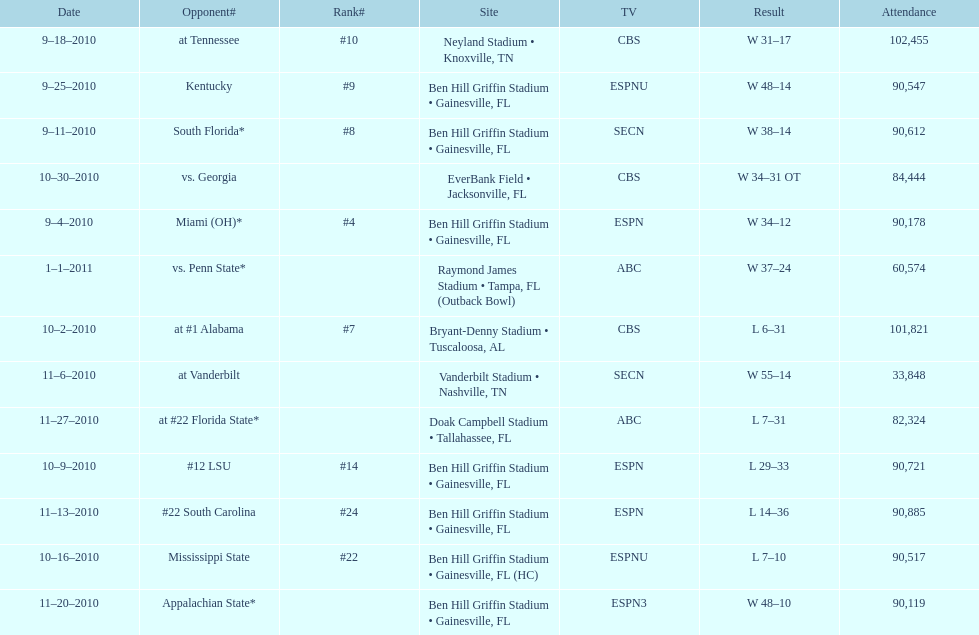Write the full table. {'header': ['Date', 'Opponent#', 'Rank#', 'Site', 'TV', 'Result', 'Attendance'], 'rows': [['9–18–2010', 'at\xa0Tennessee', '#10', 'Neyland Stadium • Knoxville, TN', 'CBS', 'W\xa031–17', '102,455'], ['9–25–2010', 'Kentucky', '#9', 'Ben Hill Griffin Stadium • Gainesville, FL', 'ESPNU', 'W\xa048–14', '90,547'], ['9–11–2010', 'South Florida*', '#8', 'Ben Hill Griffin Stadium • Gainesville, FL', 'SECN', 'W\xa038–14', '90,612'], ['10–30–2010', 'vs.\xa0Georgia', '', 'EverBank Field • Jacksonville, FL', 'CBS', 'W\xa034–31\xa0OT', '84,444'], ['9–4–2010', 'Miami (OH)*', '#4', 'Ben Hill Griffin Stadium • Gainesville, FL', 'ESPN', 'W\xa034–12', '90,178'], ['1–1–2011', 'vs.\xa0Penn State*', '', 'Raymond James Stadium • Tampa, FL (Outback Bowl)', 'ABC', 'W\xa037–24', '60,574'], ['10–2–2010', 'at\xa0#1\xa0Alabama', '#7', 'Bryant-Denny Stadium • Tuscaloosa, AL', 'CBS', 'L\xa06–31', '101,821'], ['11–6–2010', 'at\xa0Vanderbilt', '', 'Vanderbilt Stadium • Nashville, TN', 'SECN', 'W\xa055–14', '33,848'], ['11–27–2010', 'at\xa0#22\xa0Florida State*', '', 'Doak Campbell Stadium • Tallahassee, FL', 'ABC', 'L\xa07–31', '82,324'], ['10–9–2010', '#12\xa0LSU', '#14', 'Ben Hill Griffin Stadium • Gainesville, FL', 'ESPN', 'L\xa029–33', '90,721'], ['11–13–2010', '#22\xa0South Carolina', '#24', 'Ben Hill Griffin Stadium • Gainesville, FL', 'ESPN', 'L\xa014–36', '90,885'], ['10–16–2010', 'Mississippi State', '#22', 'Ben Hill Griffin Stadium • Gainesville, FL (HC)', 'ESPNU', 'L\xa07–10', '90,517'], ['11–20–2010', 'Appalachian State*', '', 'Ben Hill Griffin Stadium • Gainesville, FL', 'ESPN3', 'W\xa048–10', '90,119']]} What tv network showed the largest number of games during the 2010/2011 season? ESPN. 